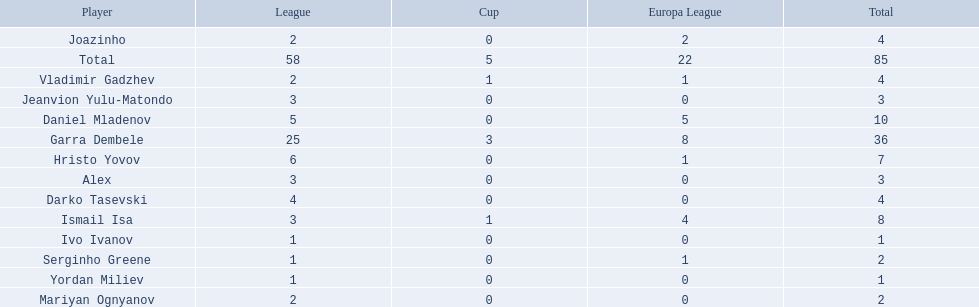What league is 2? 2, 2, 2. Which cup is less than 1? 0, 0. Which total is 2? 2. Who is the player? Mariyan Ognyanov. 